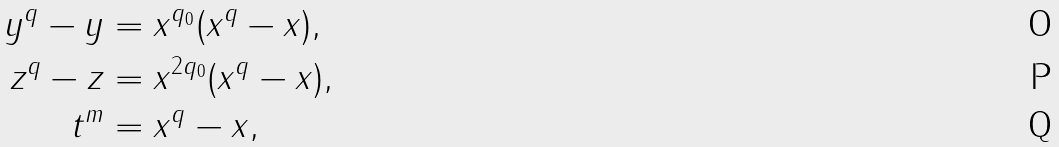Convert formula to latex. <formula><loc_0><loc_0><loc_500><loc_500>y ^ { q } - y & = x ^ { q _ { 0 } } ( x ^ { q } - x ) , \\ z ^ { q } - z & = x ^ { 2 q _ { 0 } } ( x ^ { q } - x ) , \\ t ^ { m } & = x ^ { q } - x ,</formula> 